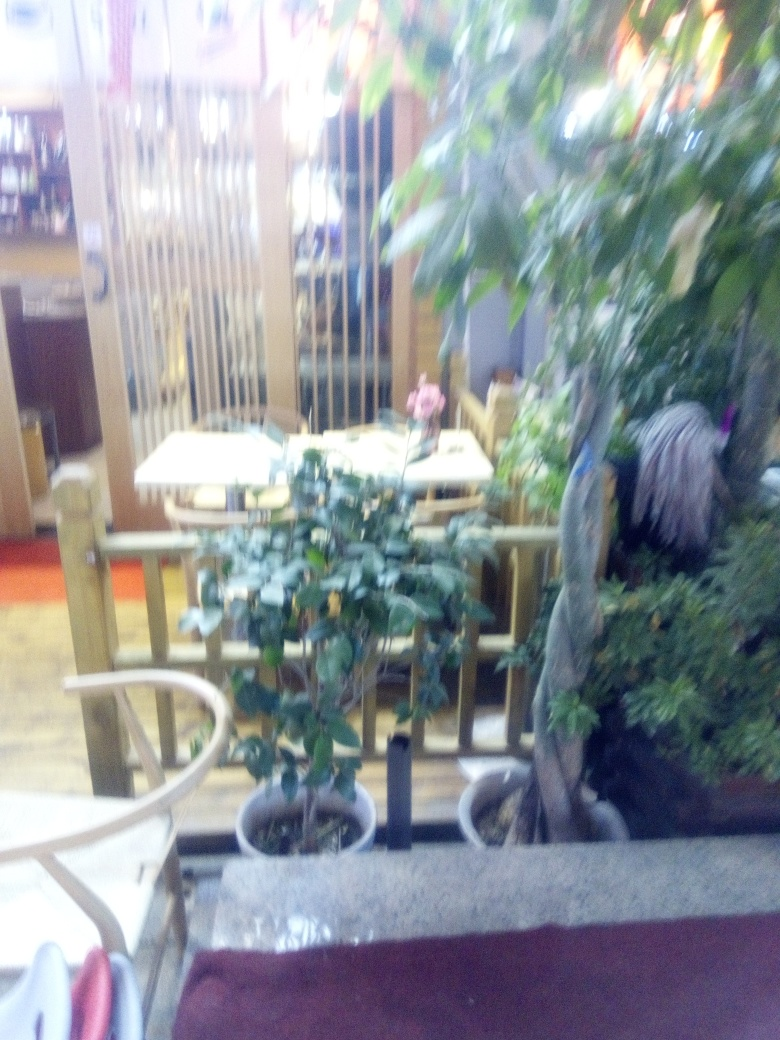Is the image sharp?
A. No
B. Yes
Answer with the option's letter from the given choices directly.
 A. 